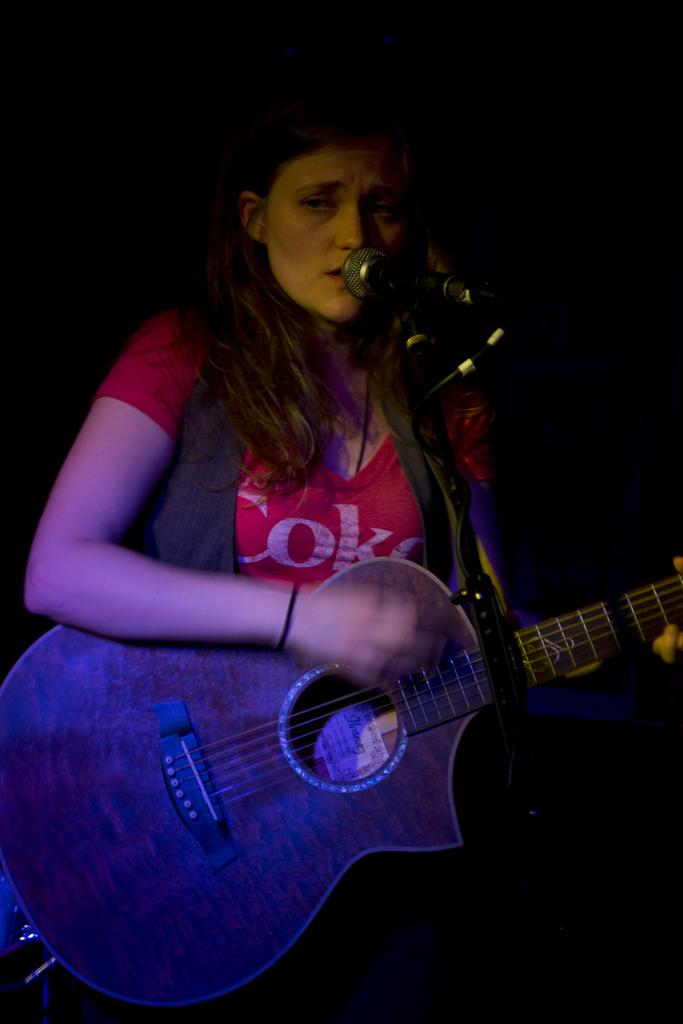Who is the main subject in the image? There is a woman in the image. What is the woman doing in the image? The woman is playing a guitar. What object is present in the image that is commonly used for amplifying sound? There is a microphone in the image. Can you see any squirrels playing with friends in the town in the image? There are no squirrels, friends, or town present in the image; it features a woman playing a guitar with a microphone nearby. 